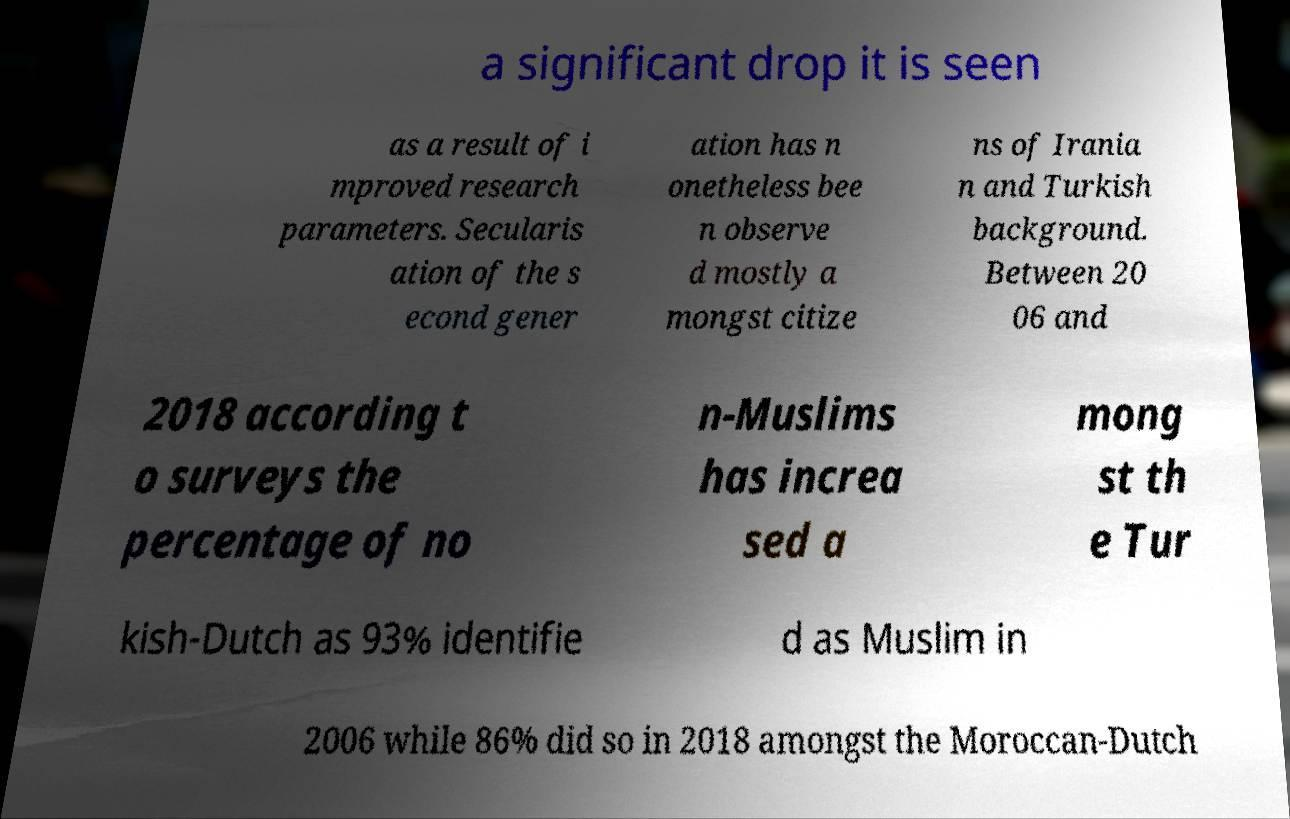What messages or text are displayed in this image? I need them in a readable, typed format. a significant drop it is seen as a result of i mproved research parameters. Secularis ation of the s econd gener ation has n onetheless bee n observe d mostly a mongst citize ns of Irania n and Turkish background. Between 20 06 and 2018 according t o surveys the percentage of no n-Muslims has increa sed a mong st th e Tur kish-Dutch as 93% identifie d as Muslim in 2006 while 86% did so in 2018 amongst the Moroccan-Dutch 